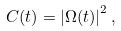<formula> <loc_0><loc_0><loc_500><loc_500>C ( t ) = \left | \Omega ( t ) \right | ^ { 2 } ,</formula> 